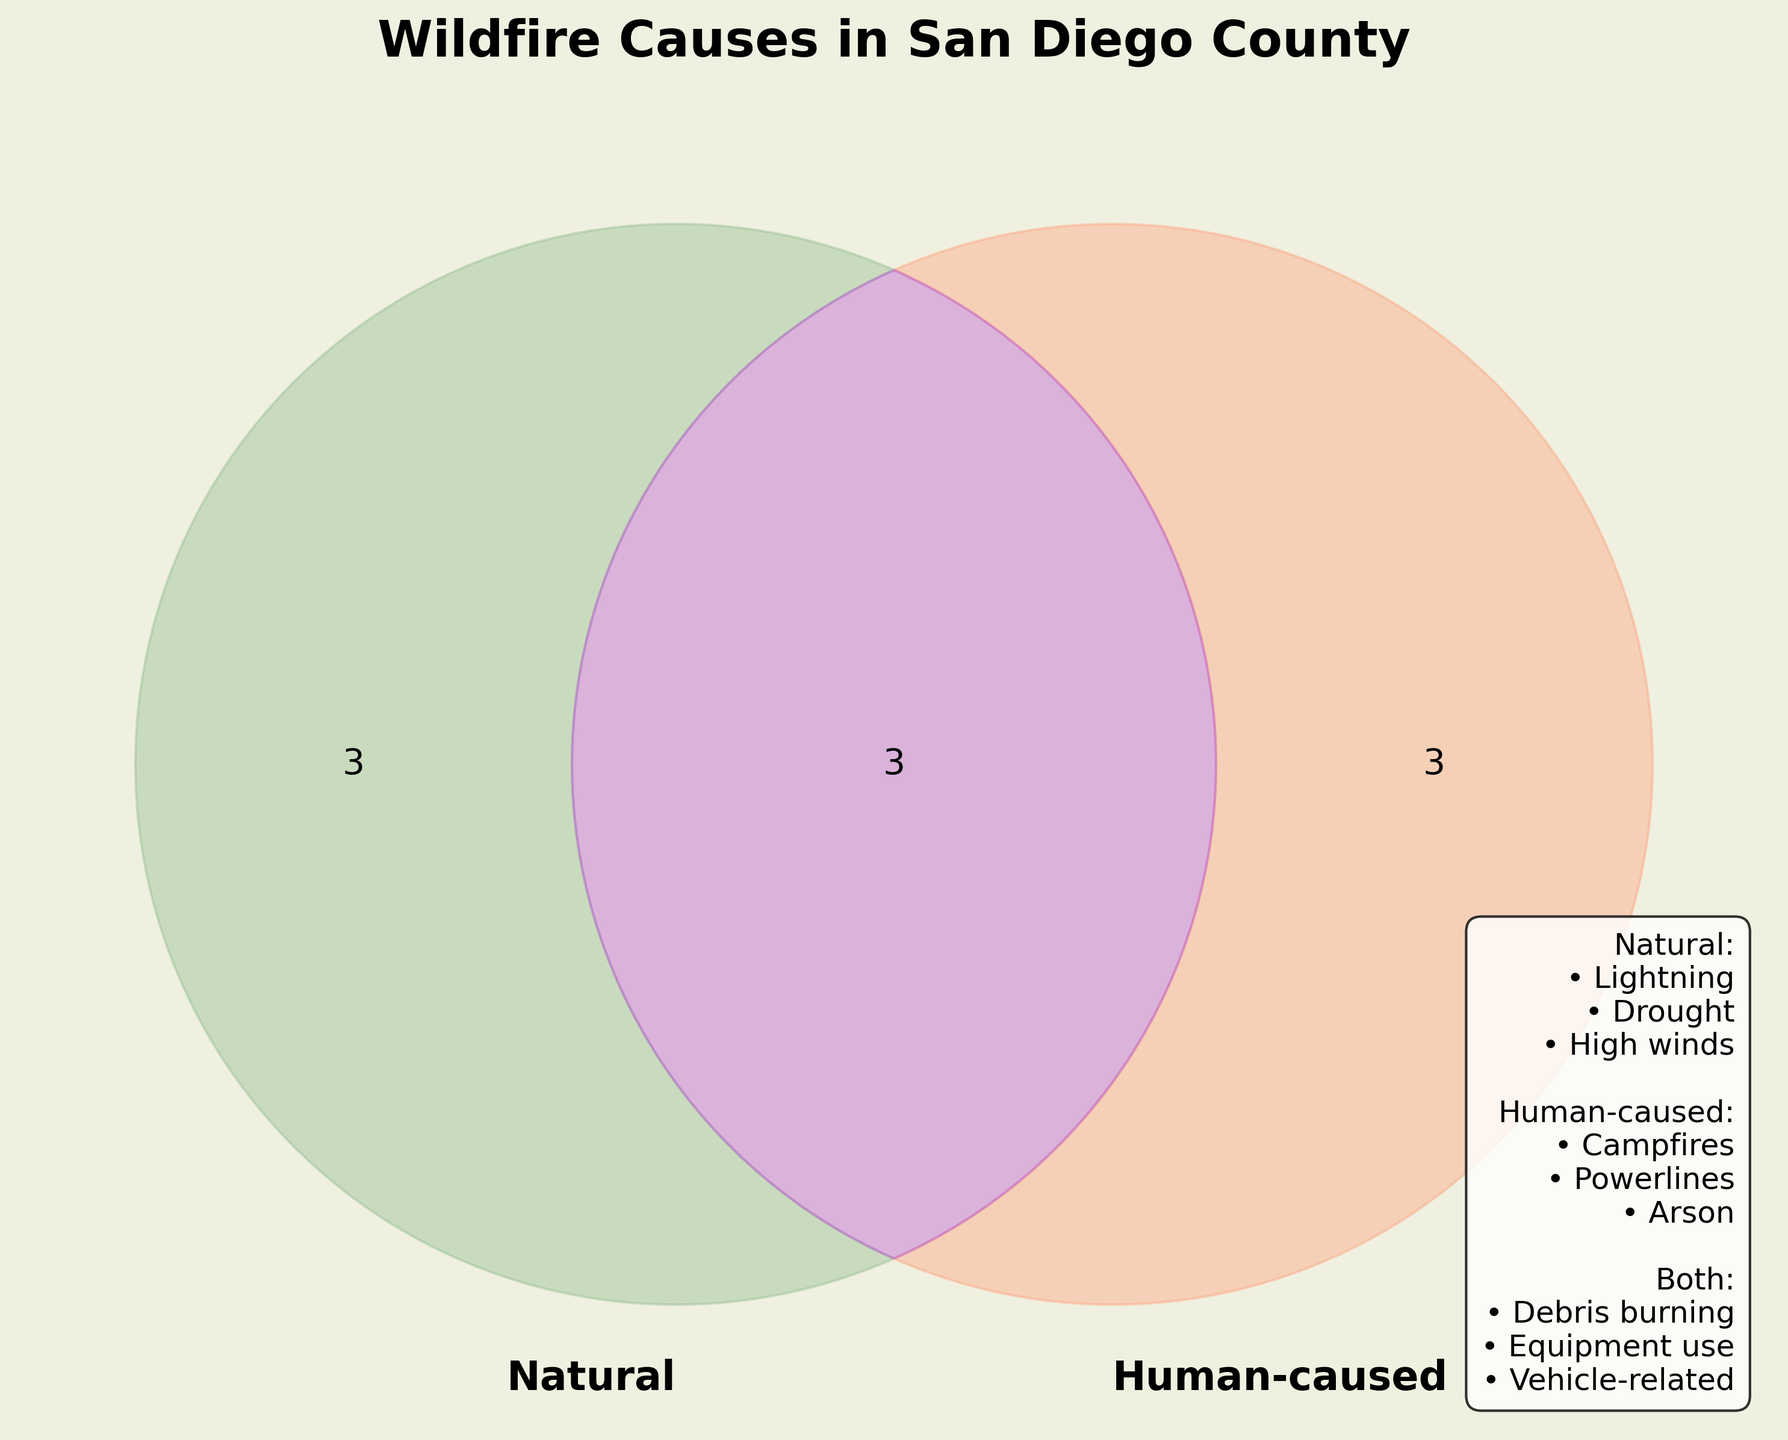What is the title of the figure? The title is prominently displayed at the top of the Venn Diagram in bold and large font. It reads "Wildfire Causes in San Diego County."
Answer: Wildfire Causes in San Diego County What causes are listed under "Natural"? The custom text in the bottom right lists the causes. For "Natural": Lightning, Drought, and High winds are mentioned.
Answer: Lightning, Drought, High winds Which category has the most causes? The Venn Diagram has three main categories. Natural and Human-caused both have three causes, but "Both" has three shared causes. As a tie, provide the category names.
Answer: Natural, Human-caused, Both What are the colors used for the "Human-caused" and "Both" circles? The Venn Diagram uses different colors to distinguish categories. "Human-caused" is represented by a light salmon color, and "Both" by a medium orchid color.
Answer: Salmon (Human-caused), Orchid (Both) How many total causes are listed in the diagram? By summing up the unique causes in Natural, Human-caused, and Both, keeping in mind that "Both" causes should be included once. Natural (3) + Human-caused (3) + Both (3 unique) = 9 total causes.
Answer: 9 Which category includes "Campfires" and are there any other causes shared with it? Campfires are listed under "Human-caused," and it is not listed as shared with any other category in the custom text.
Answer: Human-caused; No shared causes How many causes are common to both Natural and Human-caused categories? In the Venn Diagram, the overlap region (Both) has 3 causes listed: Debris burning, Equipment use, and Vehicle-related incidents.
Answer: 3 Which category does "Drought conditions" belong to? According to the custom text, "Drought conditions" are under the "Natural" category.
Answer: Natural Which causes listed under "Both" are also potentially attributed to humans? "Both" indicates shared causes that could be linked to both Natural and Human elements. From the list and common knowledge, Debris burning, Equipment use, and Vehicle-related incidents can all be human-related.
Answer: Debris burning, Equipment use, Vehicle-related incidents Compare the number of causes in the "Natural" and "Both" categories. Which has more? The Venn Diagram and custom text show both "Natural" and "Both" have 3 causes each. Therefore, they have an equal number of causes.
Answer: Equal 